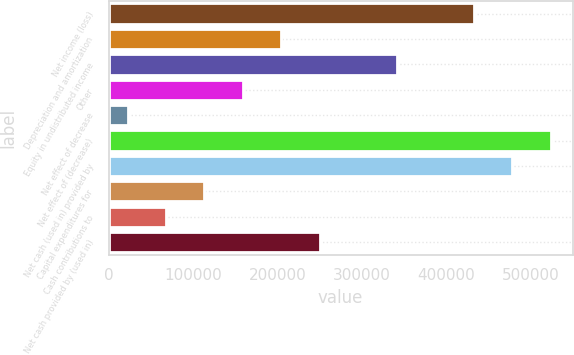<chart> <loc_0><loc_0><loc_500><loc_500><bar_chart><fcel>Net income (loss)<fcel>Depreciation and amortization<fcel>Equity in undistributed income<fcel>Other<fcel>Net effect of decrease<fcel>Net effect of (decrease)<fcel>Net cash (used in) provided by<fcel>Capital expenditures for<fcel>Cash contributions to<fcel>Net cash provided by (used in)<nl><fcel>432814<fcel>204832<fcel>341621<fcel>159235<fcel>22446<fcel>524006<fcel>478410<fcel>113639<fcel>68042.4<fcel>250428<nl></chart> 